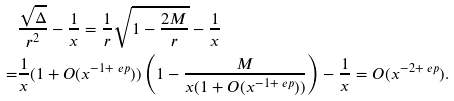Convert formula to latex. <formula><loc_0><loc_0><loc_500><loc_500>& \frac { \sqrt { \Delta } } { r ^ { 2 } } - \frac { 1 } { x } = \frac { 1 } { r } \sqrt { 1 - \frac { 2 M } { r } } - \frac { 1 } { x } \\ = & \frac { 1 } { x } ( 1 + O ( x ^ { - 1 + \ e p } ) ) \left ( 1 - \frac { M } { x ( 1 + O ( x ^ { - 1 + \ e p } ) ) } \right ) - \frac { 1 } { x } = O ( x ^ { - 2 + \ e p } ) .</formula> 